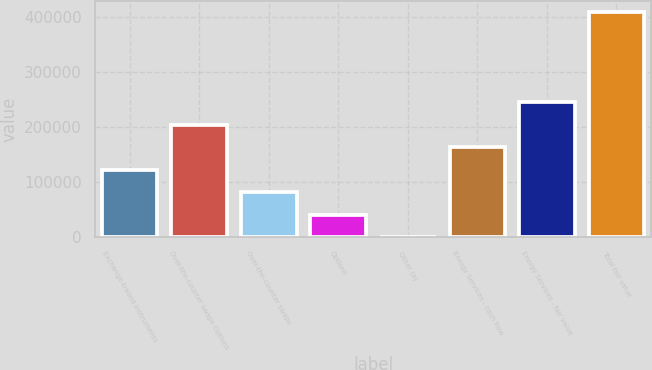<chart> <loc_0><loc_0><loc_500><loc_500><bar_chart><fcel>Exchange-traded instruments<fcel>Over-the-counter swaps Options<fcel>Over-the-counter swaps<fcel>Options<fcel>Other (a)<fcel>Energy Services - cash flow<fcel>Energy Services - fair value<fcel>Total fair value<nl><fcel>122863<fcel>204533<fcel>82028<fcel>41193<fcel>358<fcel>163698<fcel>245368<fcel>408708<nl></chart> 